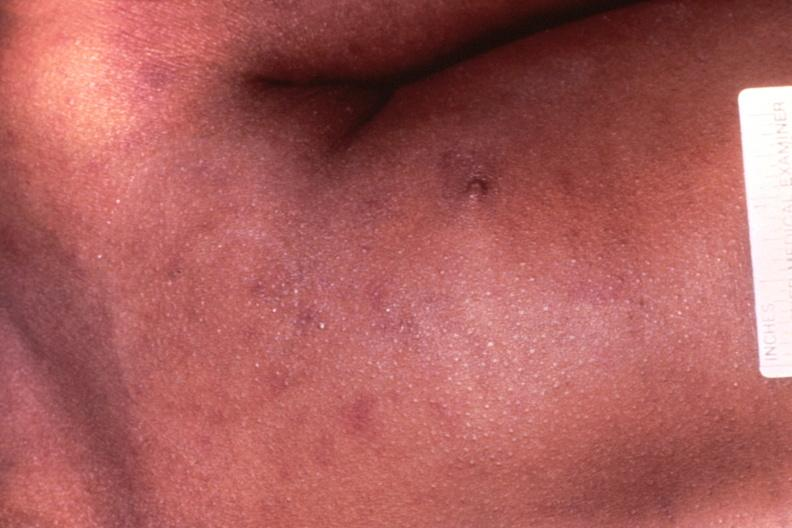does this image show meningococcemia, petechia?
Answer the question using a single word or phrase. Yes 